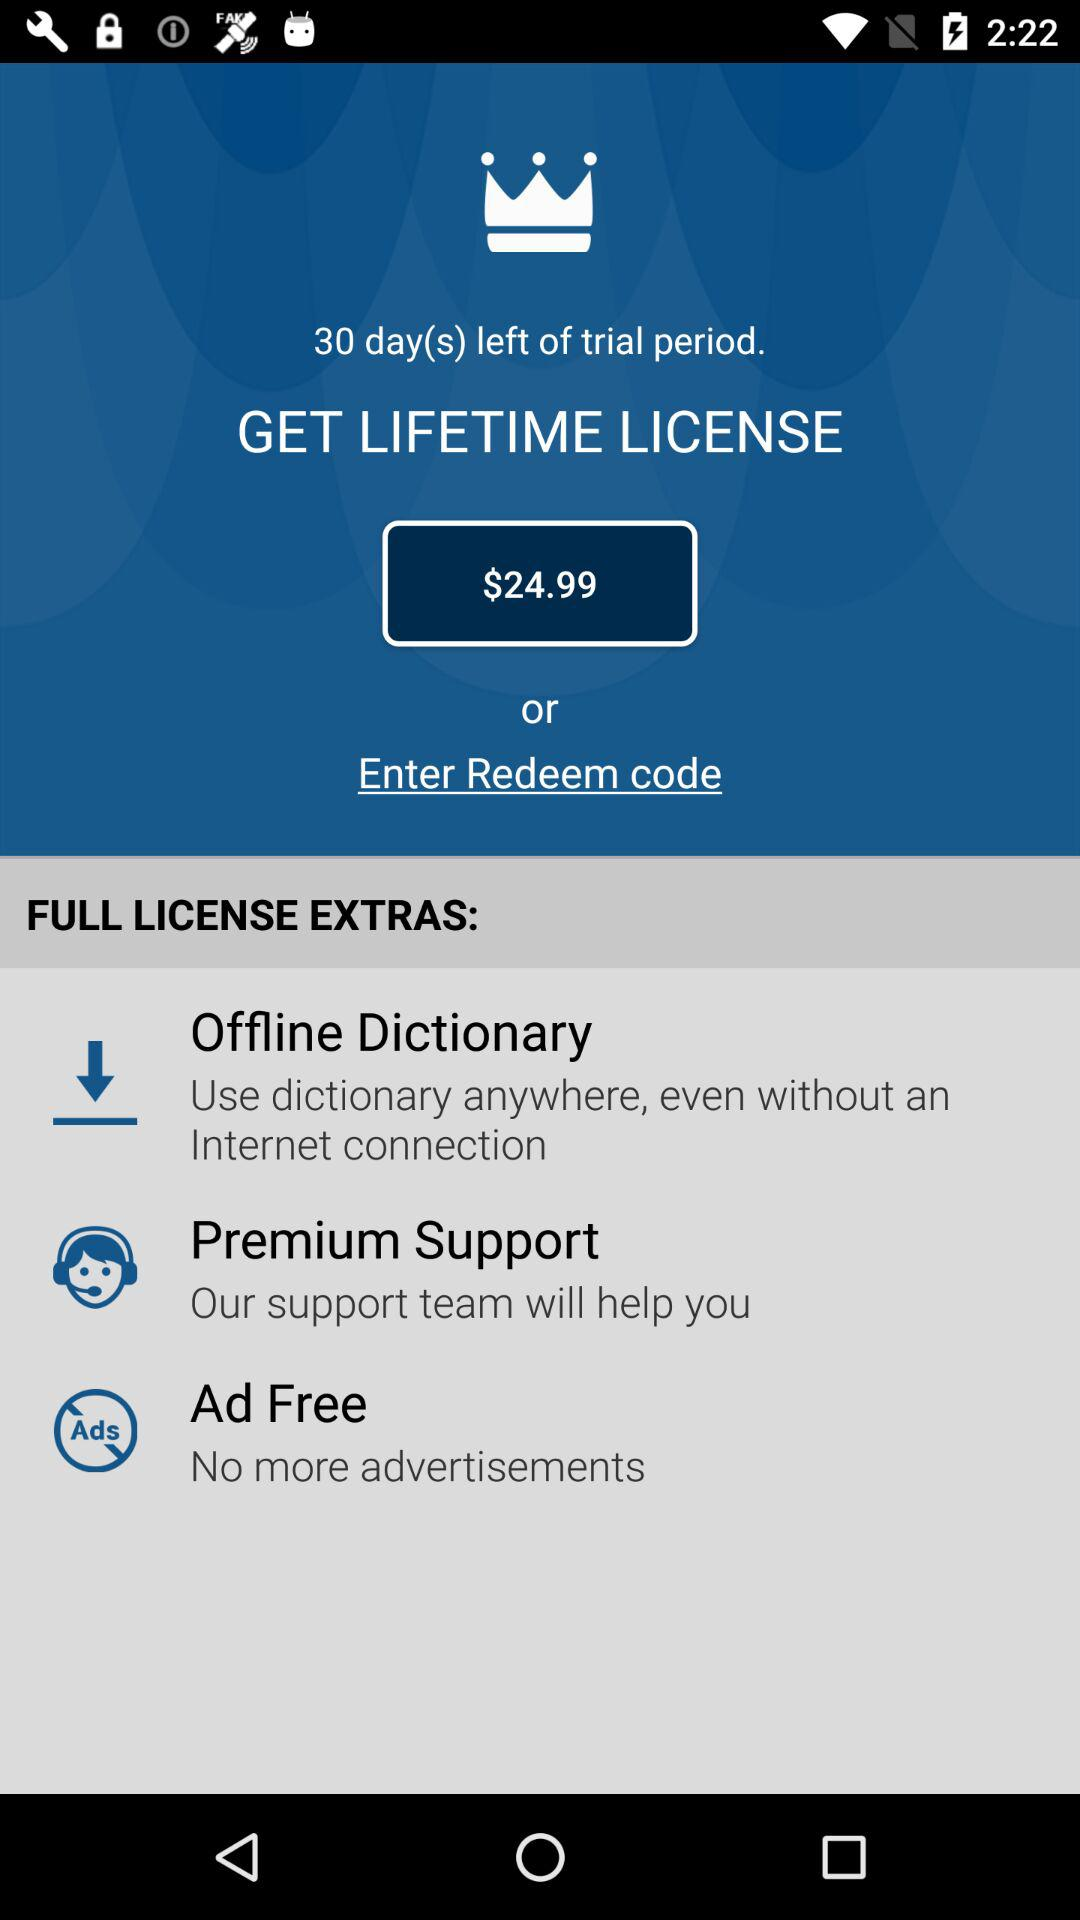What are the extra features of the full license? The extra features are "Offline Dictionary", "Premium Support" and "Ad Free". 